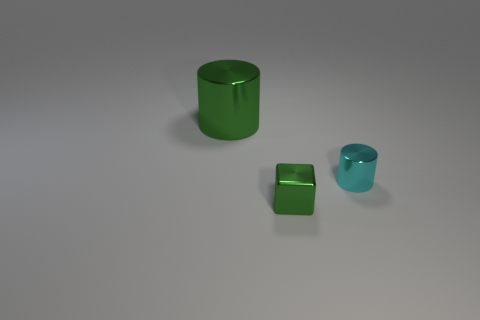What materials do the objects in the image appear to be made of? The objects exude a smooth, reflective quality indicative of a synthetic material, perhaps a type of plastic or polished resin, adding a sleek aesthetic to their geometric forms. 